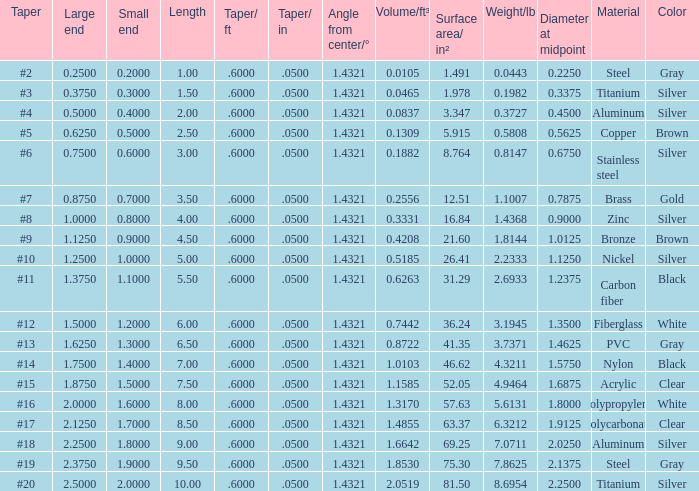Which Taper/ft that has a Large end smaller than 0.5, and a Taper of #2? 0.6. 